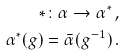<formula> <loc_0><loc_0><loc_500><loc_500>* \colon \alpha \rightarrow \alpha ^ { * } \, , \\ \alpha ^ { * } ( g ) = { \bar { \alpha } } ( g ^ { - 1 } ) \, .</formula> 